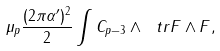<formula> <loc_0><loc_0><loc_500><loc_500>\mu _ { p } \frac { ( 2 \pi \alpha ^ { \prime } ) ^ { 2 } } { 2 } \int C _ { p - 3 } \wedge \ t r F \wedge F ,</formula> 